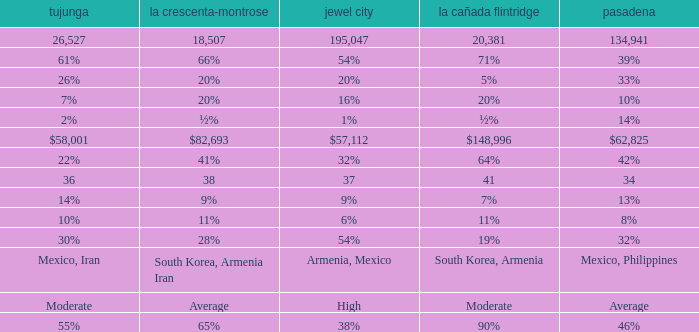What is the percentage of Glendale when Pasadena is 14%? 1%. 